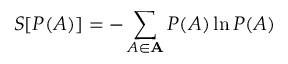Convert formula to latex. <formula><loc_0><loc_0><loc_500><loc_500>S [ P ( A ) ] = - \sum _ { A \in A } P ( A ) \ln P ( A )</formula> 